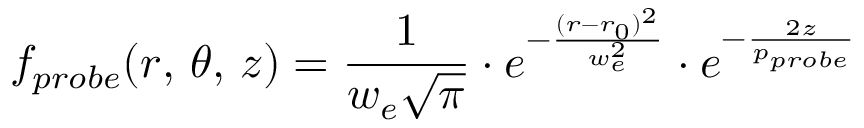Convert formula to latex. <formula><loc_0><loc_0><loc_500><loc_500>f _ { p r o b e } ( r , \, \theta , \, z ) = \frac { 1 } { w _ { e } \sqrt { \pi } } \cdot e ^ { - \frac { ( r - r _ { 0 } ) ^ { 2 } } { w _ { e } ^ { 2 } } } \cdot e ^ { - \frac { 2 z } { p _ { p r o b e } } }</formula> 